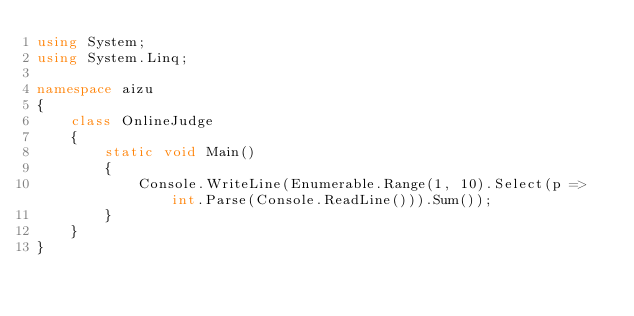Convert code to text. <code><loc_0><loc_0><loc_500><loc_500><_C#_>using System;
using System.Linq;

namespace aizu
{
    class OnlineJudge
    {
        static void Main()
        {
            Console.WriteLine(Enumerable.Range(1, 10).Select(p => int.Parse(Console.ReadLine())).Sum());
        }
    }
}</code> 